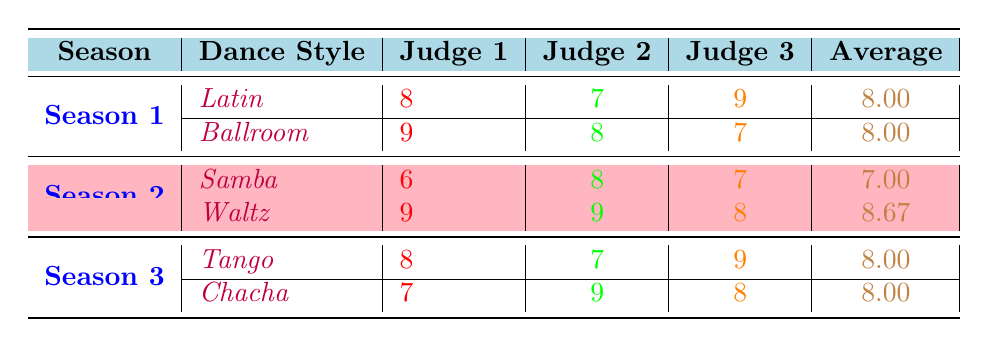What is the average score for the Samba in Season 2? The average score for the Samba is directly listed in the table under Season 2, which shows it as 7.00
Answer: 7.00 Which judge scored the highest for the Waltz in Season 2? In the table, the scores for the Waltz show Judge 1, Judge 2, and Judge 3 scoring 9, 9, and 8 respectively. The highest score is 9, given by both Judge 1 and Judge 2.
Answer: Judge 1 and Judge 2 What was the lowest score of Judge 1 across all seasons? In the table, the only score given by Judge 1 that is lower than others is the Samba in Season 2, where Judge 1 scored a 6. That is the lowest compared to other scores in the table.
Answer: 6 Is the average score for Latin in Season 1 higher than the average score for Samba in Season 2? The average score for Latin in Season 1 is 8.00, while the average score for Samba in Season 2 is 7.00. Since 8.00 is greater than 7.00, the statement is true.
Answer: Yes What is the combined average score of the Tango and Chacha in Season 3? The average score for Tango is 8.00 and for Chacha it is 8.00. To find the combined average, we calculate (8.00 + 8.00) / 2 = 8.00.
Answer: 8.00 Which dance style received the highest average score among all seasons? The highest average score among all style averages listed is for Waltz in Season 2, which has an average of 8.67. All others are either 8.00 or lower.
Answer: Waltz Did any judge give a score of 9 to a dance style in Season 3? Checking the scores for Season 3, Judge 1 scored 9 for Tango, confirming that a score of 9 was given in that season.
Answer: Yes What is the total score given by Judge 3 for all dance styles in Season 1? For Season 1, Judge 3 scored 9 for Latin and 7 for Ballroom. Adding these scores together gives us 9 + 7 = 16.
Answer: 16 